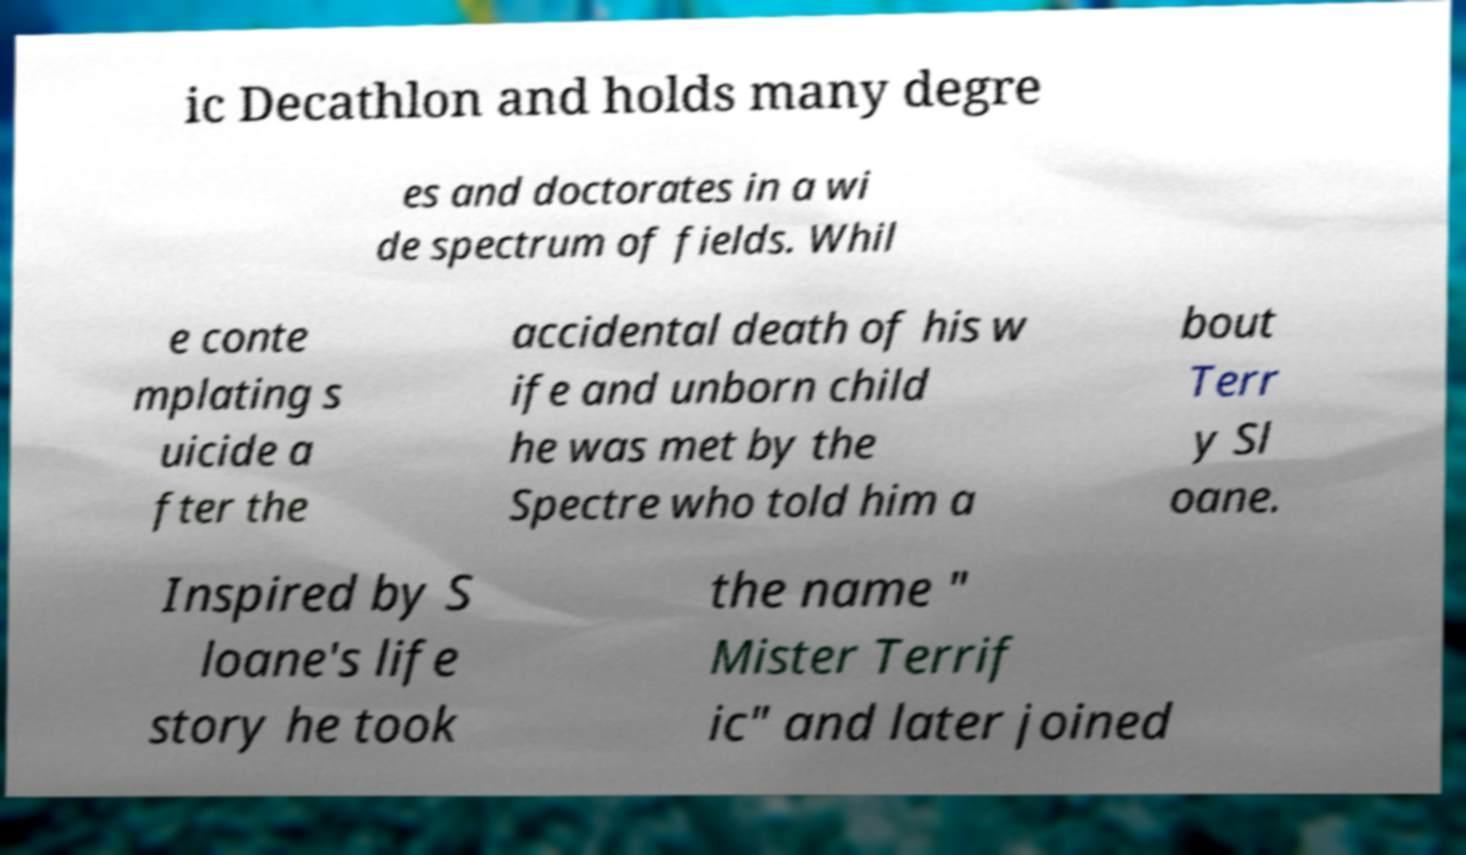Can you accurately transcribe the text from the provided image for me? ic Decathlon and holds many degre es and doctorates in a wi de spectrum of fields. Whil e conte mplating s uicide a fter the accidental death of his w ife and unborn child he was met by the Spectre who told him a bout Terr y Sl oane. Inspired by S loane's life story he took the name " Mister Terrif ic" and later joined 